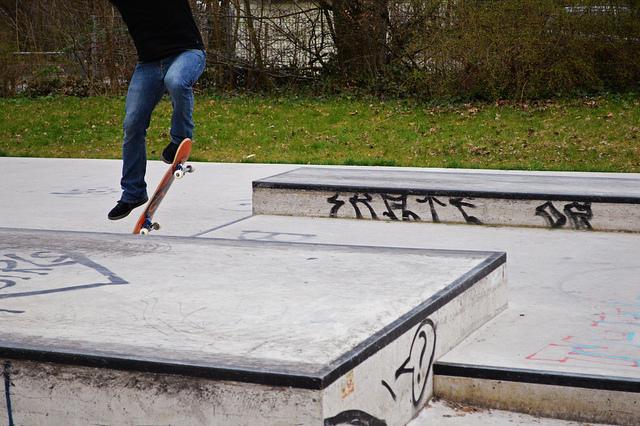Is this a parking garage?
Answer briefly. No. Is there grass in the image?
Concise answer only. Yes. What kind of art is featured on the walls of this skate park?
Be succinct. Graffiti. Is the skater wearing any safety gear?
Answer briefly. No. 